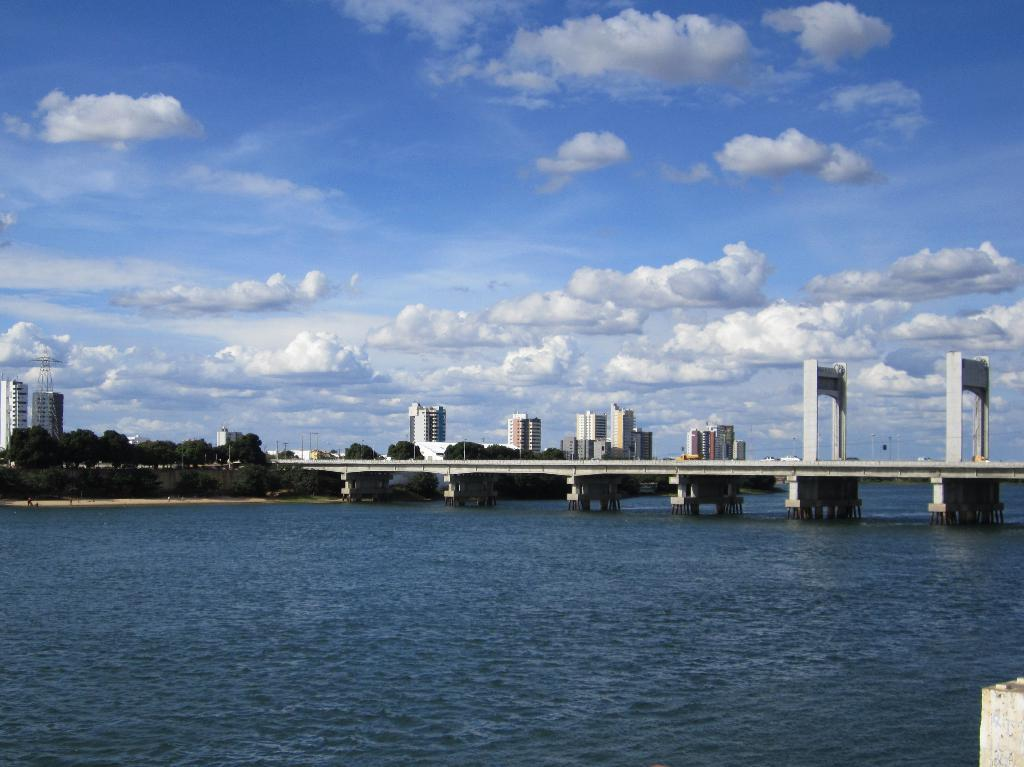What type of natural feature is present in the image? There is a river in the image. What structure is built on the river? There is a bridge on the river. What type of vegetation is near the river? There are trees near the river. What type of man-made structures are near the river? There are buildings near the river. What type of corn is growing near the river in the image? There is no corn present in the image; it features a river, a bridge, trees, and buildings. 